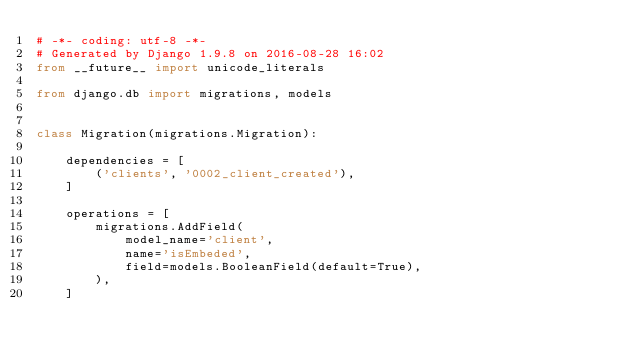<code> <loc_0><loc_0><loc_500><loc_500><_Python_># -*- coding: utf-8 -*-
# Generated by Django 1.9.8 on 2016-08-28 16:02
from __future__ import unicode_literals

from django.db import migrations, models


class Migration(migrations.Migration):

    dependencies = [
        ('clients', '0002_client_created'),
    ]

    operations = [
        migrations.AddField(
            model_name='client',
            name='isEmbeded',
            field=models.BooleanField(default=True),
        ),
    ]
</code> 